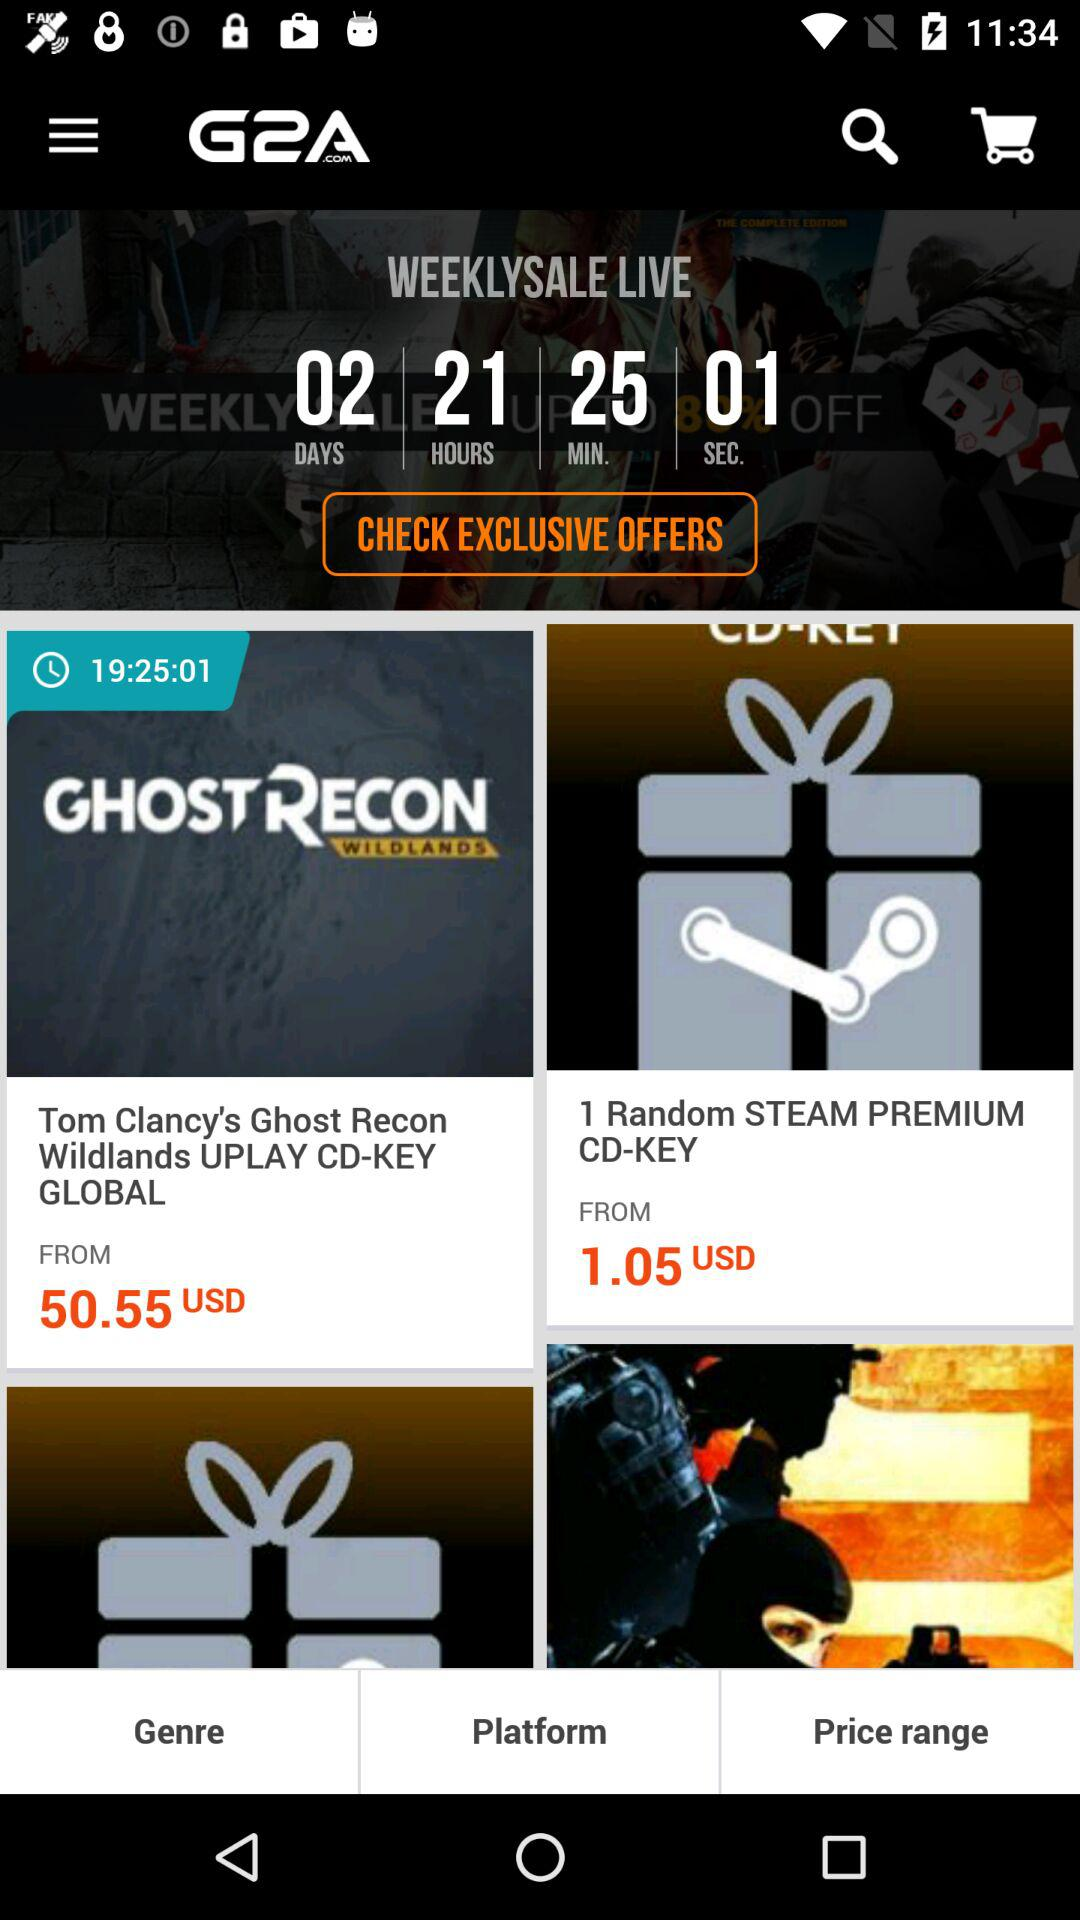How many more USD is the most expensive item than the cheapest item?
Answer the question using a single word or phrase. 49.5 